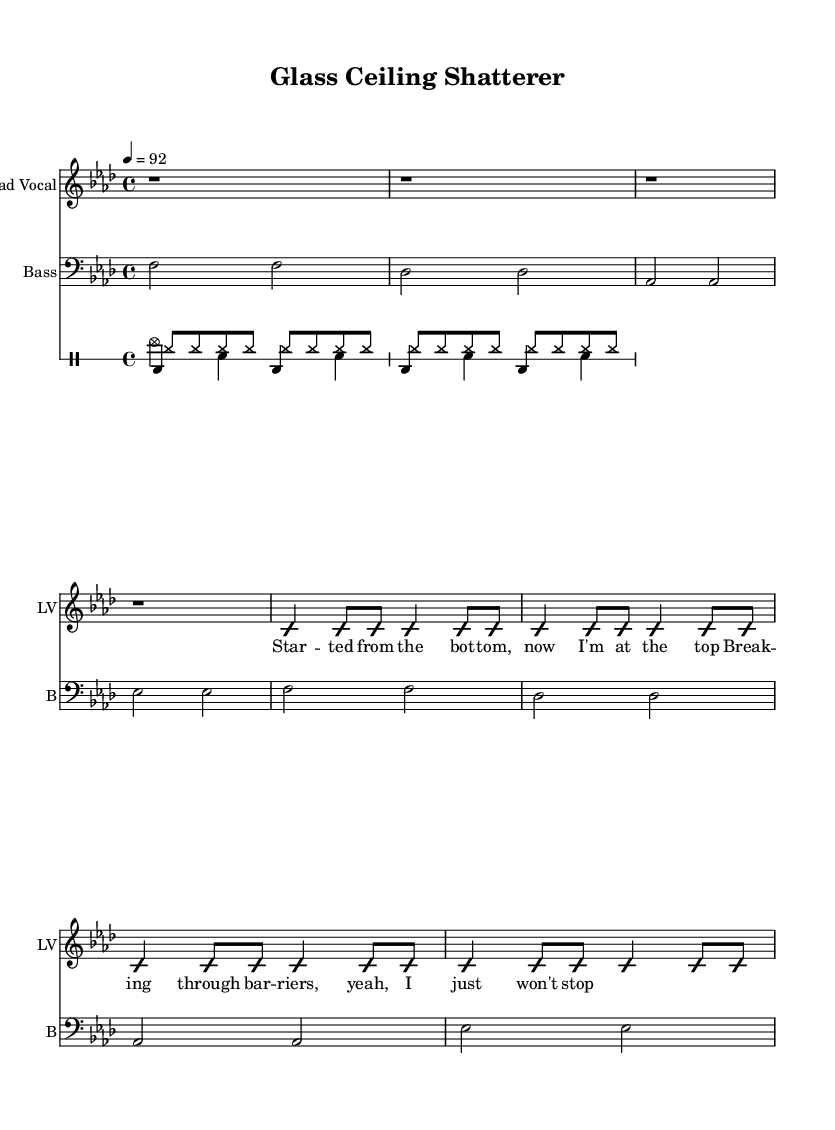What is the key signature of this music? The key signature indicated in the music sheet is F minor, which has four flats: B♭, E♭, A♭, and D♭.
Answer: F minor What is the time signature in this piece? The time signature is located at the beginning of the score and indicates the meter. In this case, it is 4/4, meaning there are four beats per measure and the quarter note gets one beat.
Answer: 4/4 What is the tempo marking for the song? The tempo marking is found in the score above the staff, indicating the speed of the piece. It states 4 = 92, meaning there are 92 beats per minute.
Answer: 92 How many measures are in the lead vocal part? By examining the lead vocal section, we count the number of measures, which are represented by vertical lines on the staff. It contains a total of 8 measures.
Answer: 8 What is the style of the rhythm used in the drums? The drum patterns are characterized by a consistent and strong beat structure typical of rap music, which emphasizes the bass drum, snare, and hi-hat in a rhythmic manner. The style represented here includes variations in beats and accents typical to the genre.
Answer: Rap How many different drum voices are included? The score shows that there are four distinct drum voices, each represented by its own staff, allowing for separate rhythmic patterns and complexity within the percussion.
Answer: 4 